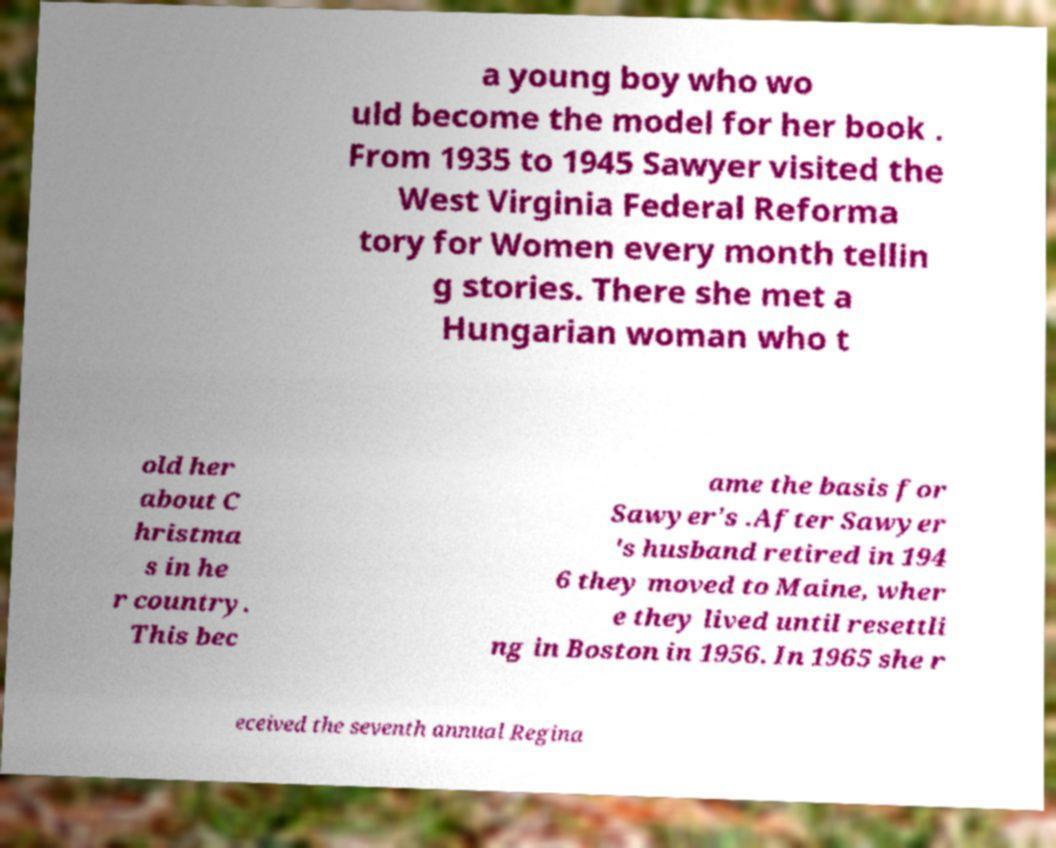Please identify and transcribe the text found in this image. a young boy who wo uld become the model for her book . From 1935 to 1945 Sawyer visited the West Virginia Federal Reforma tory for Women every month tellin g stories. There she met a Hungarian woman who t old her about C hristma s in he r country. This bec ame the basis for Sawyer's .After Sawyer 's husband retired in 194 6 they moved to Maine, wher e they lived until resettli ng in Boston in 1956. In 1965 she r eceived the seventh annual Regina 